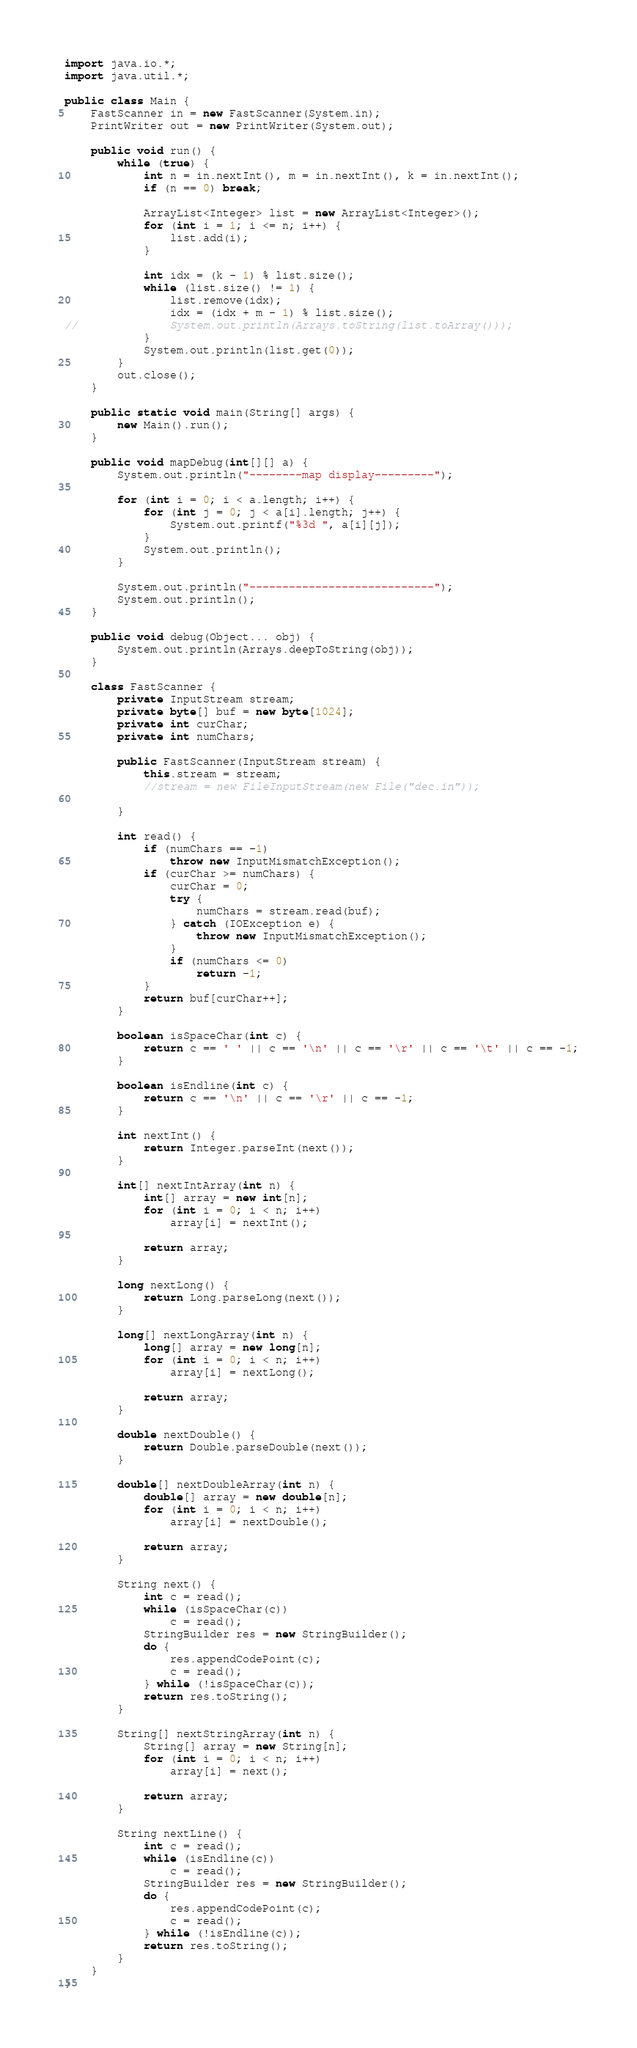<code> <loc_0><loc_0><loc_500><loc_500><_Java_>
import java.io.*;
import java.util.*;

public class Main {
	FastScanner in = new FastScanner(System.in);
	PrintWriter out = new PrintWriter(System.out);

	public void run() {
		while (true) {
			int n = in.nextInt(), m = in.nextInt(), k = in.nextInt();
			if (n == 0) break;
			
			ArrayList<Integer> list = new ArrayList<Integer>();
			for (int i = 1; i <= n; i++) {
				list.add(i);
			}
			
			int idx = (k - 1) % list.size();
			while (list.size() != 1) {
				list.remove(idx);
				idx = (idx + m - 1) % list.size();
//				System.out.println(Arrays.toString(list.toArray()));
			}
			System.out.println(list.get(0));
		}
		out.close();
	}

	public static void main(String[] args) {
		new Main().run();
	}

	public void mapDebug(int[][] a) {
		System.out.println("--------map display---------");

		for (int i = 0; i < a.length; i++) {
			for (int j = 0; j < a[i].length; j++) {
				System.out.printf("%3d ", a[i][j]);
			}
			System.out.println();
		}

		System.out.println("----------------------------");
		System.out.println();
	}

	public void debug(Object... obj) {
		System.out.println(Arrays.deepToString(obj));
	}

	class FastScanner {
		private InputStream stream;
		private byte[] buf = new byte[1024];
		private int curChar;
		private int numChars;

		public FastScanner(InputStream stream) {
			this.stream = stream;
			//stream = new FileInputStream(new File("dec.in"));

		}

		int read() {
			if (numChars == -1)
				throw new InputMismatchException();
			if (curChar >= numChars) {
				curChar = 0;
				try {
					numChars = stream.read(buf);
				} catch (IOException e) {
					throw new InputMismatchException();
				}
				if (numChars <= 0)
					return -1;
			}
			return buf[curChar++];
		}

		boolean isSpaceChar(int c) {
			return c == ' ' || c == '\n' || c == '\r' || c == '\t' || c == -1;
		}

		boolean isEndline(int c) {
			return c == '\n' || c == '\r' || c == -1;
		}

		int nextInt() {
			return Integer.parseInt(next());
		}

		int[] nextIntArray(int n) {
			int[] array = new int[n];
			for (int i = 0; i < n; i++)
				array[i] = nextInt();

			return array;
		}

		long nextLong() {
			return Long.parseLong(next());
		}

		long[] nextLongArray(int n) {
			long[] array = new long[n];
			for (int i = 0; i < n; i++)
				array[i] = nextLong();

			return array;
		}

		double nextDouble() {
			return Double.parseDouble(next());
		}

		double[] nextDoubleArray(int n) {
			double[] array = new double[n];
			for (int i = 0; i < n; i++)
				array[i] = nextDouble();

			return array;
		}

		String next() {
			int c = read();
			while (isSpaceChar(c))
				c = read();
			StringBuilder res = new StringBuilder();
			do {
				res.appendCodePoint(c);
				c = read();
			} while (!isSpaceChar(c));
			return res.toString();
		}

		String[] nextStringArray(int n) {
			String[] array = new String[n];
			for (int i = 0; i < n; i++)
				array[i] = next();

			return array;
		}

		String nextLine() {
			int c = read();
			while (isEndline(c))
				c = read();
			StringBuilder res = new StringBuilder();
			do {
				res.appendCodePoint(c);
				c = read();
			} while (!isEndline(c));
			return res.toString();
		}
	}
}</code> 